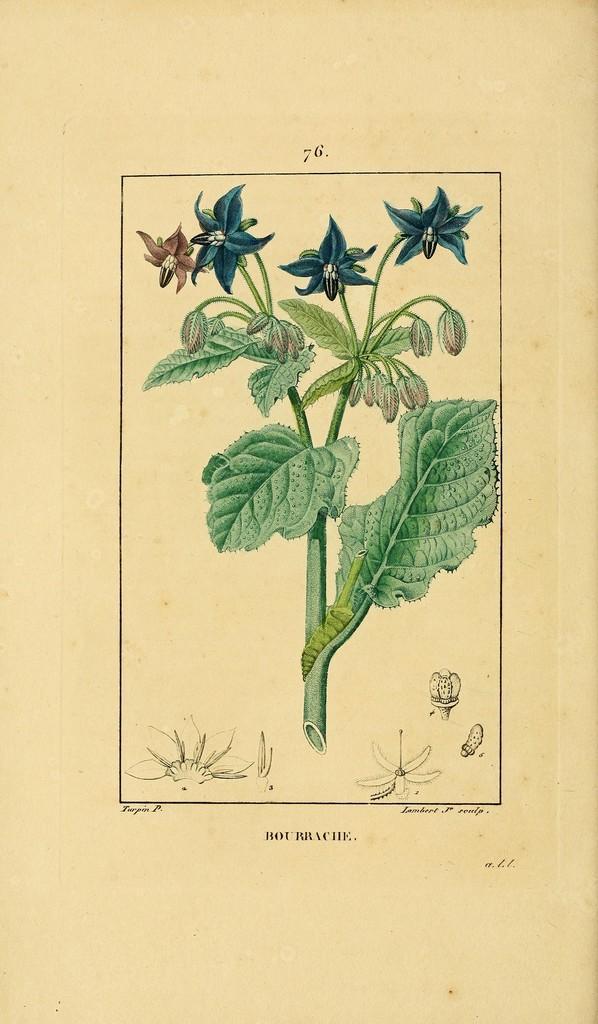Describe this image in one or two sentences. In the center of this picture we can see the drawing of a plant consists of flowers, buds and leaves. At the bottom there is a text on the image. 